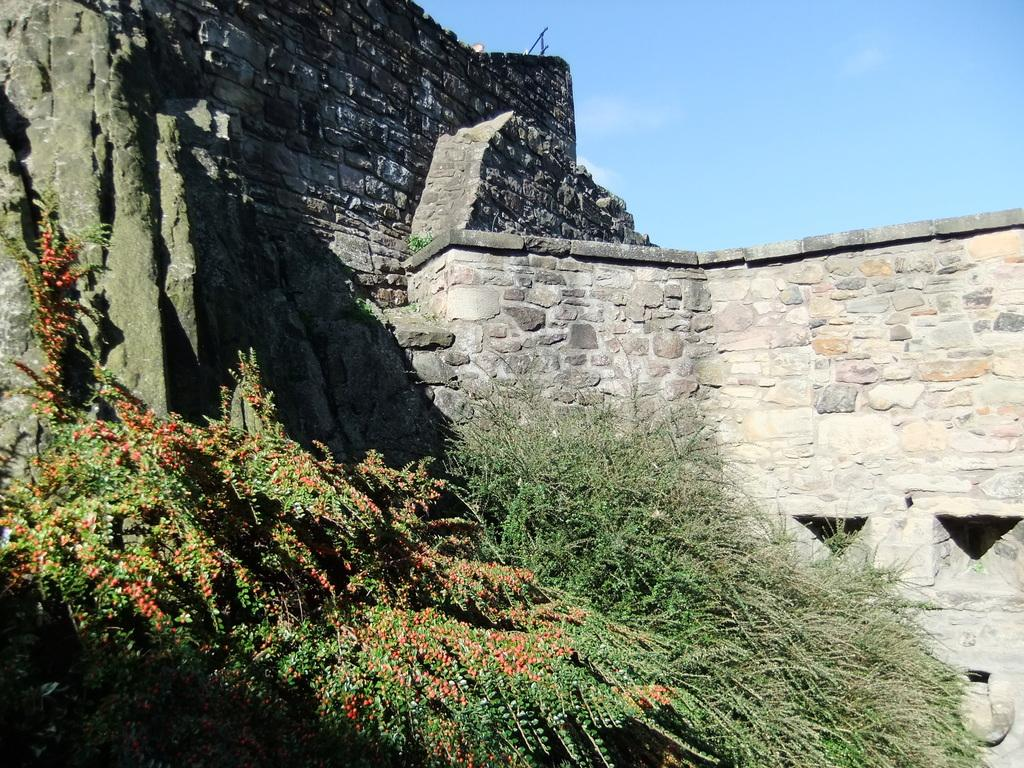What is one of the main features of the image? There is a wall in the image. What type of living organisms can be seen in the image? Plants are visible in the image. What part of the natural environment is visible in the image? The sky is visible in the image. What is the weight of the fairies flying in the image? There are no fairies present in the image, so their weight cannot be determined. 